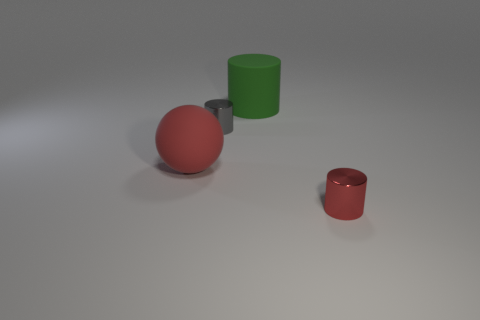Is there anything else that has the same size as the rubber ball?
Offer a very short reply. Yes. There is a object that is in front of the gray metallic thing and on the right side of the small gray cylinder; what material is it made of?
Make the answer very short. Metal. There is a red thing to the left of the metal object that is to the right of the big rubber cylinder that is on the right side of the gray metal thing; what size is it?
Provide a short and direct response. Large. There is a tiny red metallic thing; is its shape the same as the big matte object that is on the left side of the big cylinder?
Ensure brevity in your answer.  No. How many objects are behind the small red cylinder and in front of the green object?
Your answer should be compact. 2. How many red things are tiny cylinders or matte cylinders?
Keep it short and to the point. 1. Is the color of the tiny metallic thing that is in front of the big red matte object the same as the large matte thing left of the tiny gray object?
Keep it short and to the point. Yes. There is a small cylinder that is behind the red object that is in front of the large red rubber ball in front of the big green matte object; what color is it?
Ensure brevity in your answer.  Gray. Are there any red objects left of the small metallic object that is behind the large red ball?
Your response must be concise. Yes. There is a small thing that is to the left of the tiny red thing; is it the same shape as the green thing?
Give a very brief answer. Yes. 